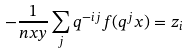<formula> <loc_0><loc_0><loc_500><loc_500>- \frac { 1 } { n x y } \sum _ { j } q ^ { - i j } f ( q ^ { j } x ) = z _ { i }</formula> 